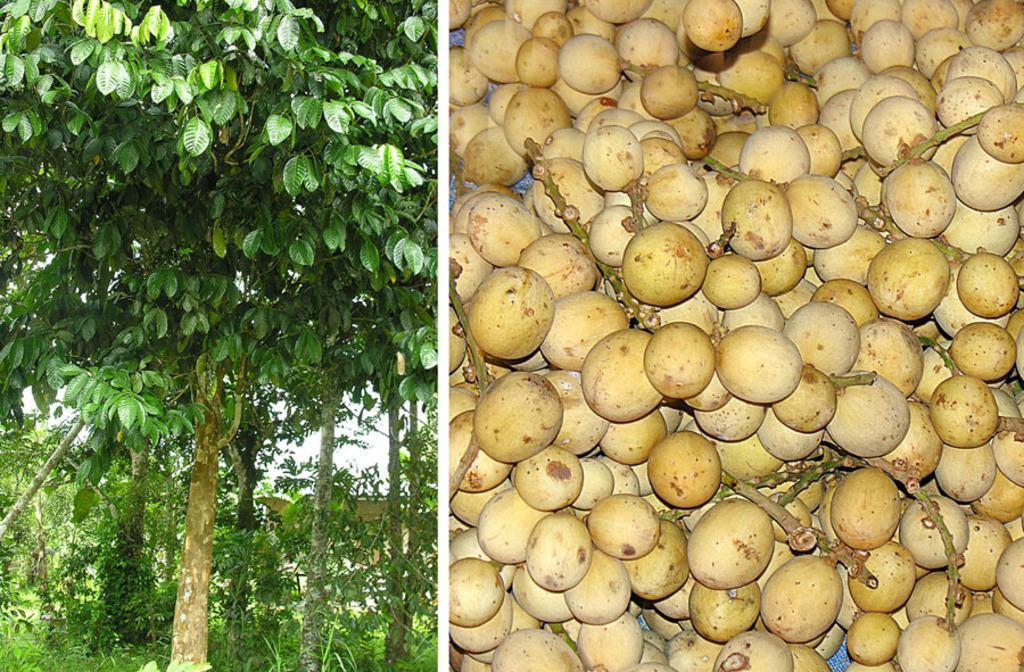How would you summarize this image in a sentence or two? This is an image with collage. On the left side we can see some trees, plants and the sky. On the right side we can see some fruits on the surface. 